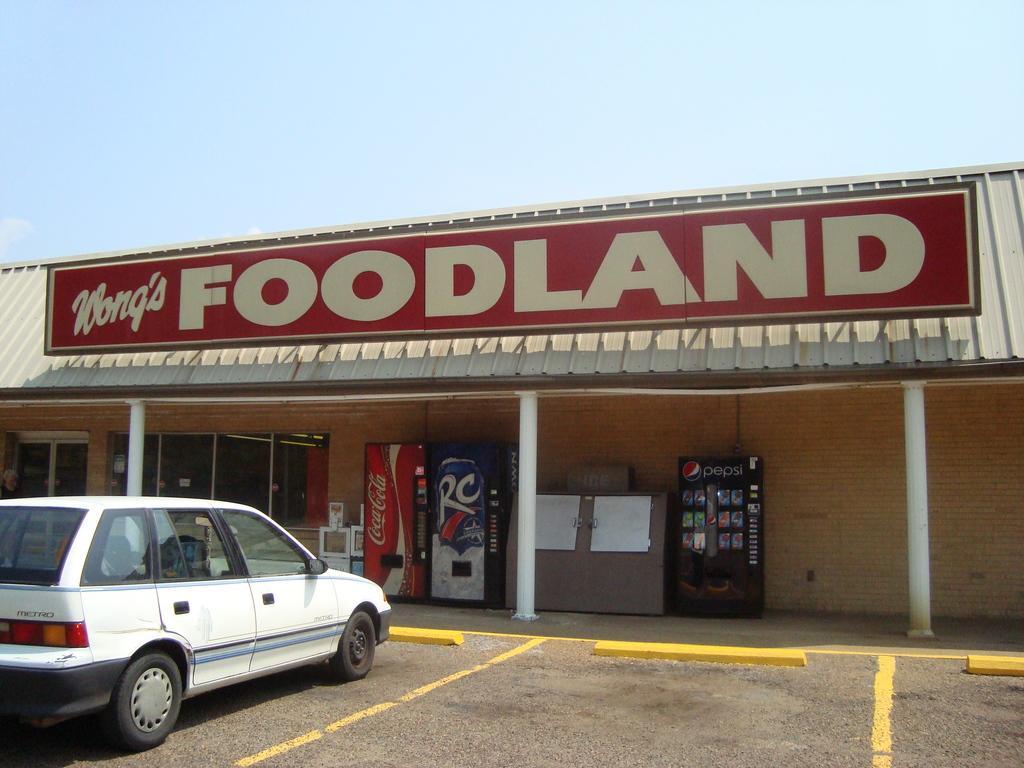Could you give a brief overview of what you see in this image? At the bottom of the picture, we see a white car parked on the road. Behind that, there are refrigerators and a notice board on which papers are placed. We see a red color hoarding board with some text written on it. At the top of the picture, we see the sky. 